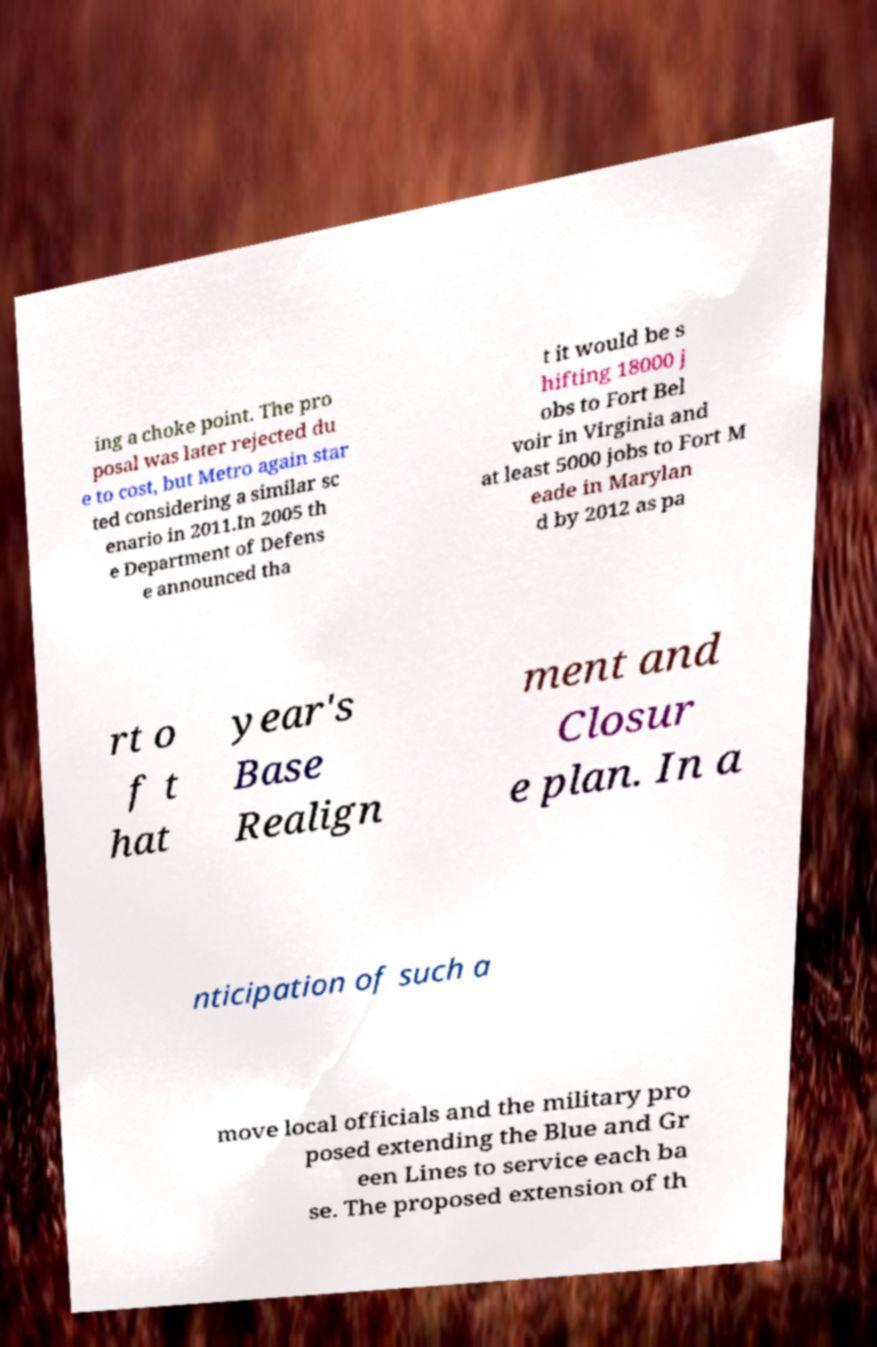For documentation purposes, I need the text within this image transcribed. Could you provide that? ing a choke point. The pro posal was later rejected du e to cost, but Metro again star ted considering a similar sc enario in 2011.In 2005 th e Department of Defens e announced tha t it would be s hifting 18000 j obs to Fort Bel voir in Virginia and at least 5000 jobs to Fort M eade in Marylan d by 2012 as pa rt o f t hat year's Base Realign ment and Closur e plan. In a nticipation of such a move local officials and the military pro posed extending the Blue and Gr een Lines to service each ba se. The proposed extension of th 